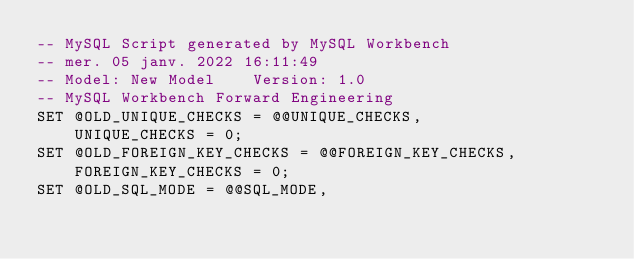<code> <loc_0><loc_0><loc_500><loc_500><_SQL_>-- MySQL Script generated by MySQL Workbench
-- mer. 05 janv. 2022 16:11:49
-- Model: New Model    Version: 1.0
-- MySQL Workbench Forward Engineering
SET @OLD_UNIQUE_CHECKS = @@UNIQUE_CHECKS,
    UNIQUE_CHECKS = 0;
SET @OLD_FOREIGN_KEY_CHECKS = @@FOREIGN_KEY_CHECKS,
    FOREIGN_KEY_CHECKS = 0;
SET @OLD_SQL_MODE = @@SQL_MODE,</code> 